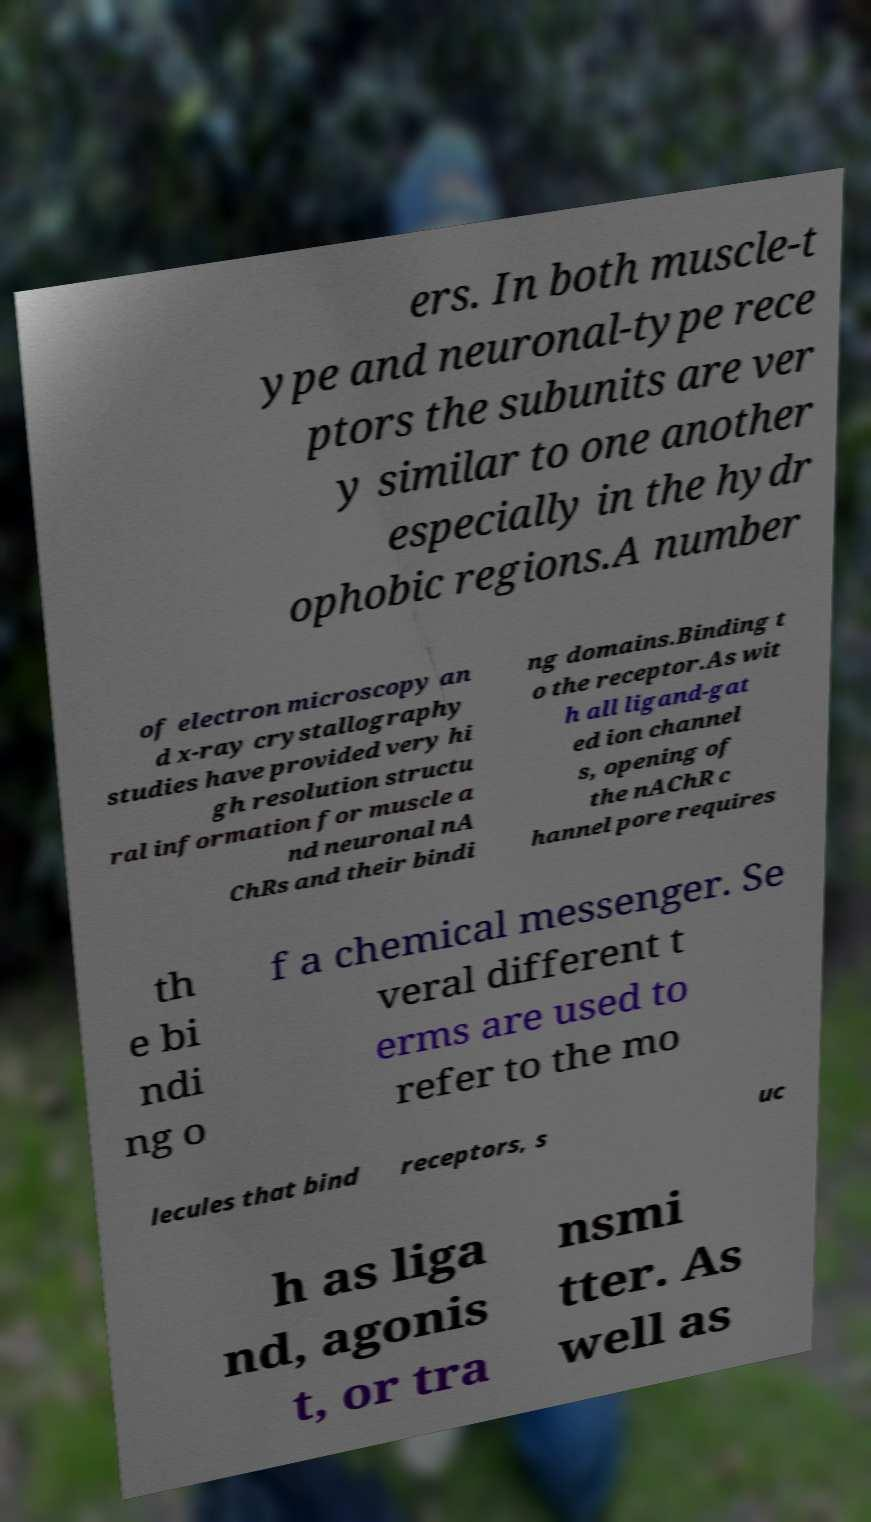Can you accurately transcribe the text from the provided image for me? ers. In both muscle-t ype and neuronal-type rece ptors the subunits are ver y similar to one another especially in the hydr ophobic regions.A number of electron microscopy an d x-ray crystallography studies have provided very hi gh resolution structu ral information for muscle a nd neuronal nA ChRs and their bindi ng domains.Binding t o the receptor.As wit h all ligand-gat ed ion channel s, opening of the nAChR c hannel pore requires th e bi ndi ng o f a chemical messenger. Se veral different t erms are used to refer to the mo lecules that bind receptors, s uc h as liga nd, agonis t, or tra nsmi tter. As well as 